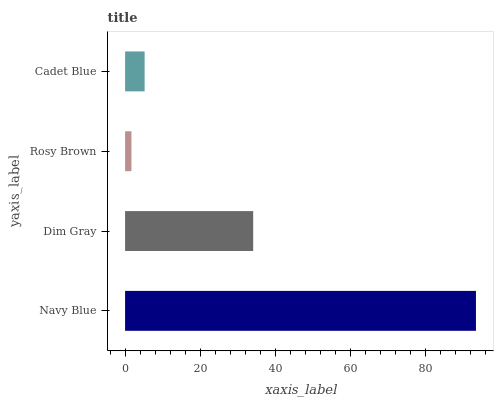Is Rosy Brown the minimum?
Answer yes or no. Yes. Is Navy Blue the maximum?
Answer yes or no. Yes. Is Dim Gray the minimum?
Answer yes or no. No. Is Dim Gray the maximum?
Answer yes or no. No. Is Navy Blue greater than Dim Gray?
Answer yes or no. Yes. Is Dim Gray less than Navy Blue?
Answer yes or no. Yes. Is Dim Gray greater than Navy Blue?
Answer yes or no. No. Is Navy Blue less than Dim Gray?
Answer yes or no. No. Is Dim Gray the high median?
Answer yes or no. Yes. Is Cadet Blue the low median?
Answer yes or no. Yes. Is Navy Blue the high median?
Answer yes or no. No. Is Rosy Brown the low median?
Answer yes or no. No. 